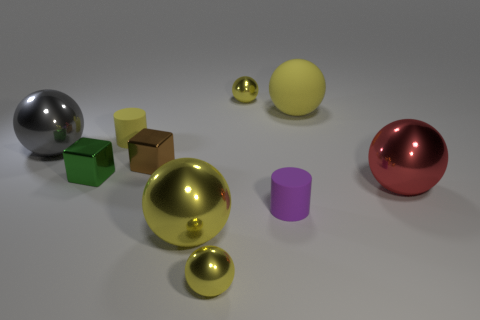Do the big gray metallic thing and the yellow object right of the purple object have the same shape?
Offer a terse response. Yes. What material is the yellow cylinder?
Your answer should be compact. Rubber. There is another rubber object that is the same shape as the gray object; what is its size?
Ensure brevity in your answer.  Large. How many other objects are the same material as the big gray ball?
Give a very brief answer. 6. Is the material of the tiny green object the same as the small yellow ball that is in front of the red sphere?
Give a very brief answer. Yes. Is the number of green metallic things that are right of the big red metal ball less than the number of big red spheres that are behind the gray metal thing?
Your response must be concise. No. There is a small matte cylinder that is on the left side of the purple thing; what is its color?
Your response must be concise. Yellow. How many other things are the same color as the big matte ball?
Keep it short and to the point. 4. Is the size of the yellow metallic thing behind the brown shiny object the same as the big gray shiny sphere?
Make the answer very short. No. There is a red sphere; what number of yellow matte cylinders are behind it?
Offer a terse response. 1. 